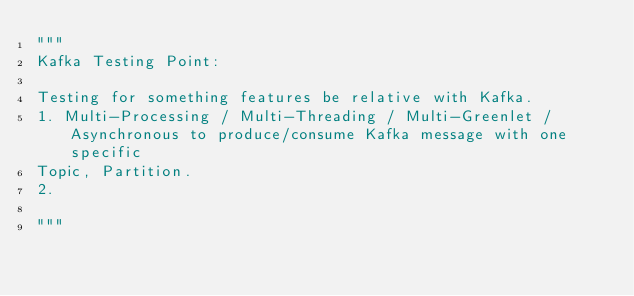<code> <loc_0><loc_0><loc_500><loc_500><_Python_>"""
Kafka Testing Point:

Testing for something features be relative with Kafka.
1. Multi-Processing / Multi-Threading / Multi-Greenlet / Asynchronous to produce/consume Kafka message with one specific
Topic, Partition.
2.

"""</code> 